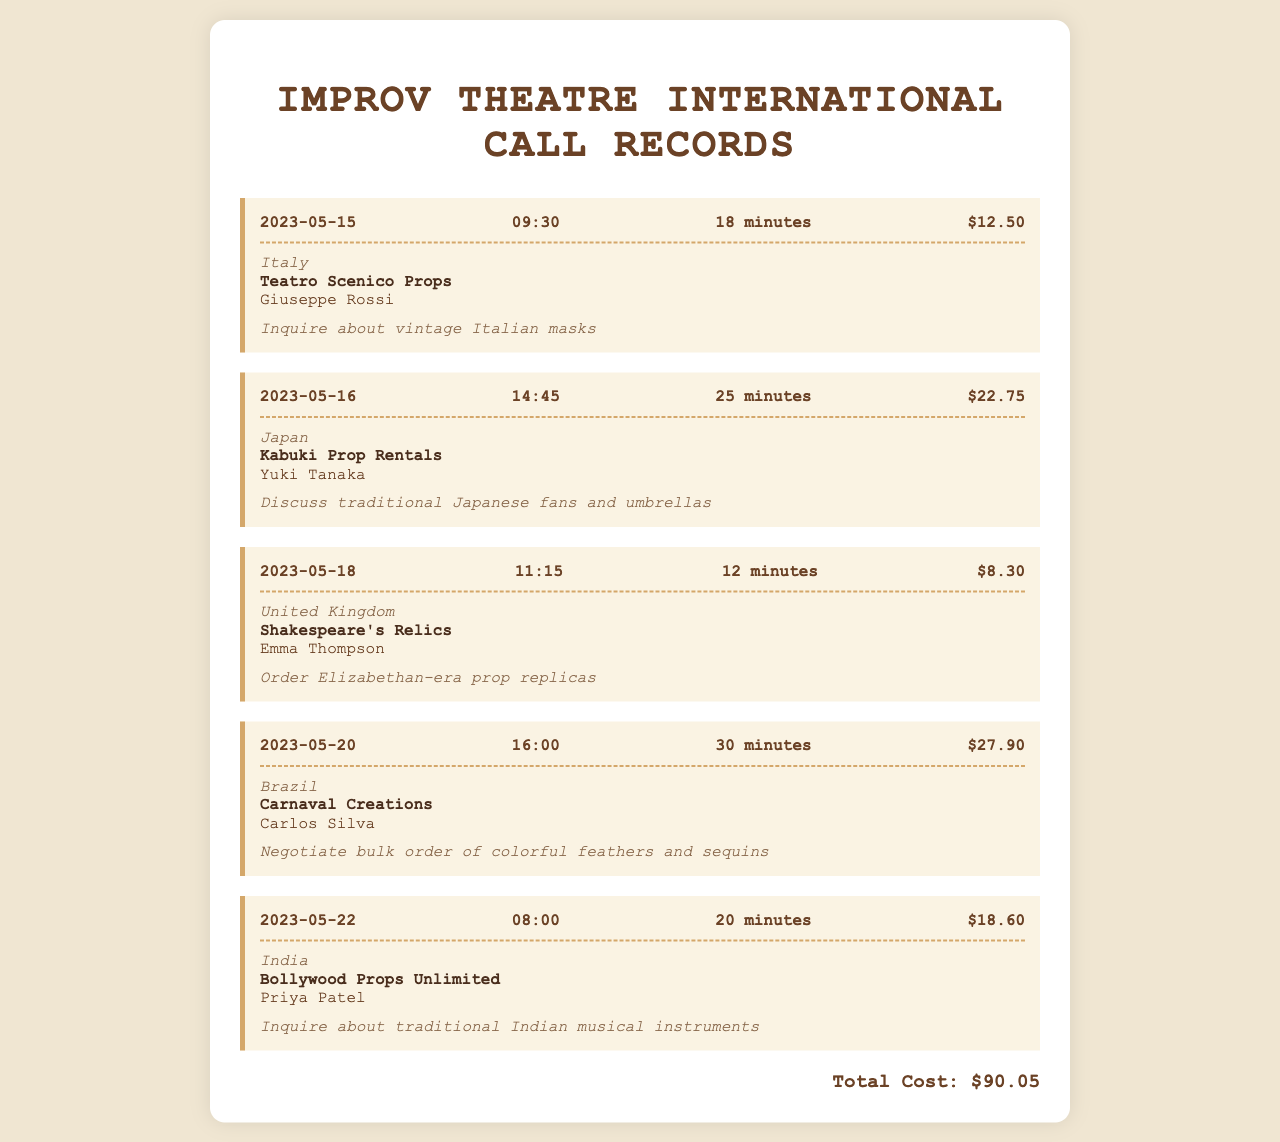What is the total cost of all calls? The total cost is explicitly stated at the bottom of the document.
Answer: $90.05 What company did we contact in Japan? The document lists the company associated with the call to Japan.
Answer: Kabuki Prop Rentals Who was the contact person for the call to Italy? The document specifies the contact name for the call to Italy.
Answer: Giuseppe Rossi What was the duration of the call to Brazil? The document provides the duration for each call, including Brazil.
Answer: 30 minutes On what date was the call to the United Kingdom made? The document clearly states the date of the call to the UK.
Answer: 2023-05-18 Which country was contacted to discuss traditional Indian musical instruments? The document includes the country relevant to the inquiry about Indian musical instruments.
Answer: India What is the purpose of the call made to Teatro Scenico Props? The document describes the purpose for each call, including the call to Italy.
Answer: Inquire about vintage Italian masks What was the cost of the call to discuss colorful feathers and sequins? The document details the cost of the call to Brazil regarding bulk orders.
Answer: $27.90 How long was the call made on May 22? The document indicates the length of the call made on that date.
Answer: 20 minutes 